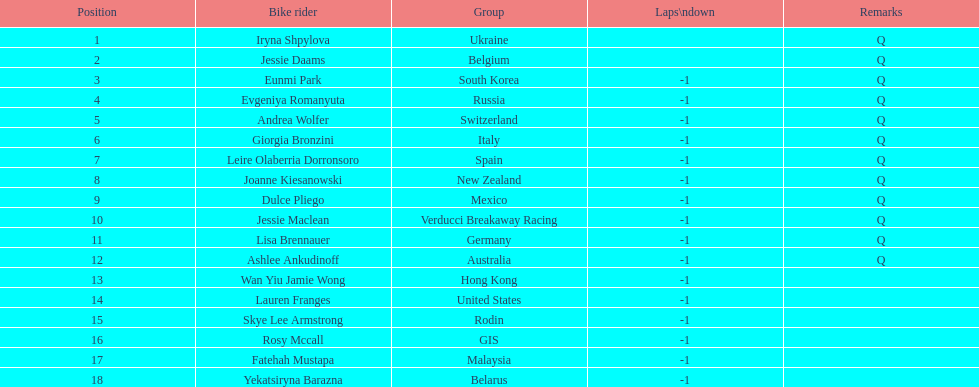What is the number rank of belgium? 2. 